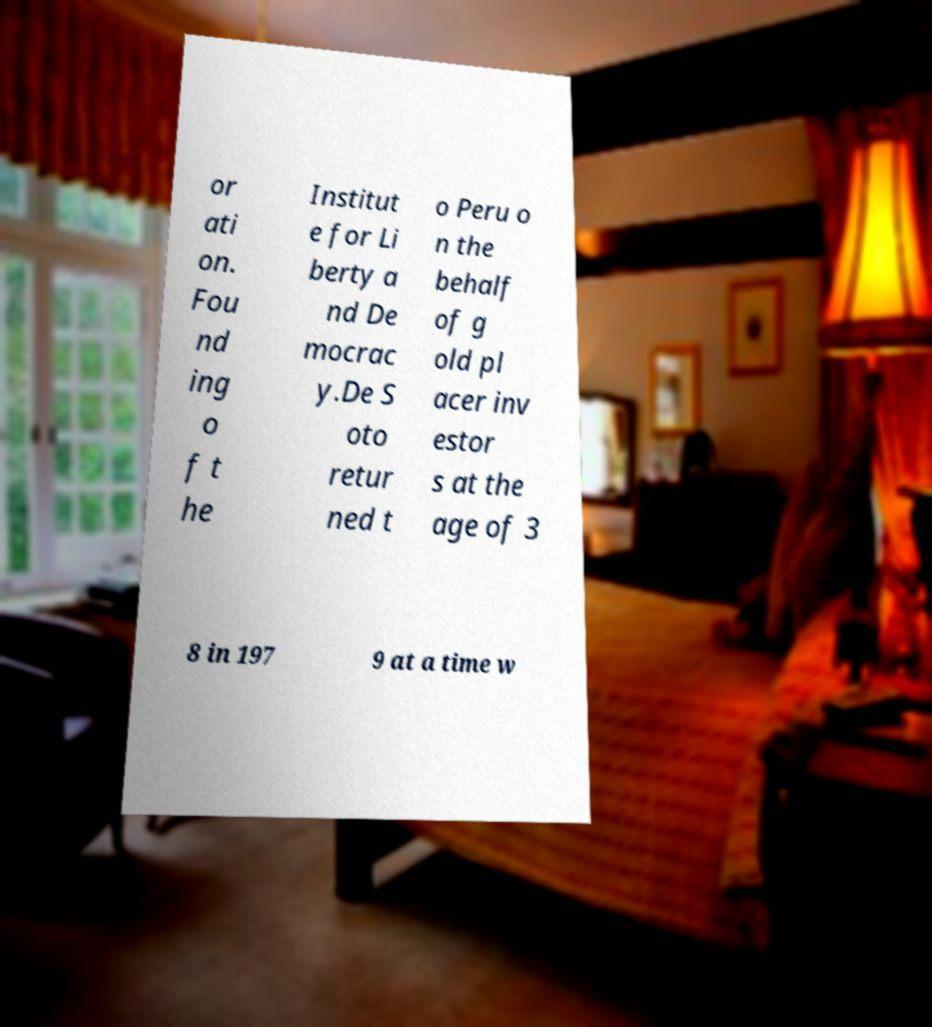I need the written content from this picture converted into text. Can you do that? or ati on. Fou nd ing o f t he Institut e for Li berty a nd De mocrac y.De S oto retur ned t o Peru o n the behalf of g old pl acer inv estor s at the age of 3 8 in 197 9 at a time w 